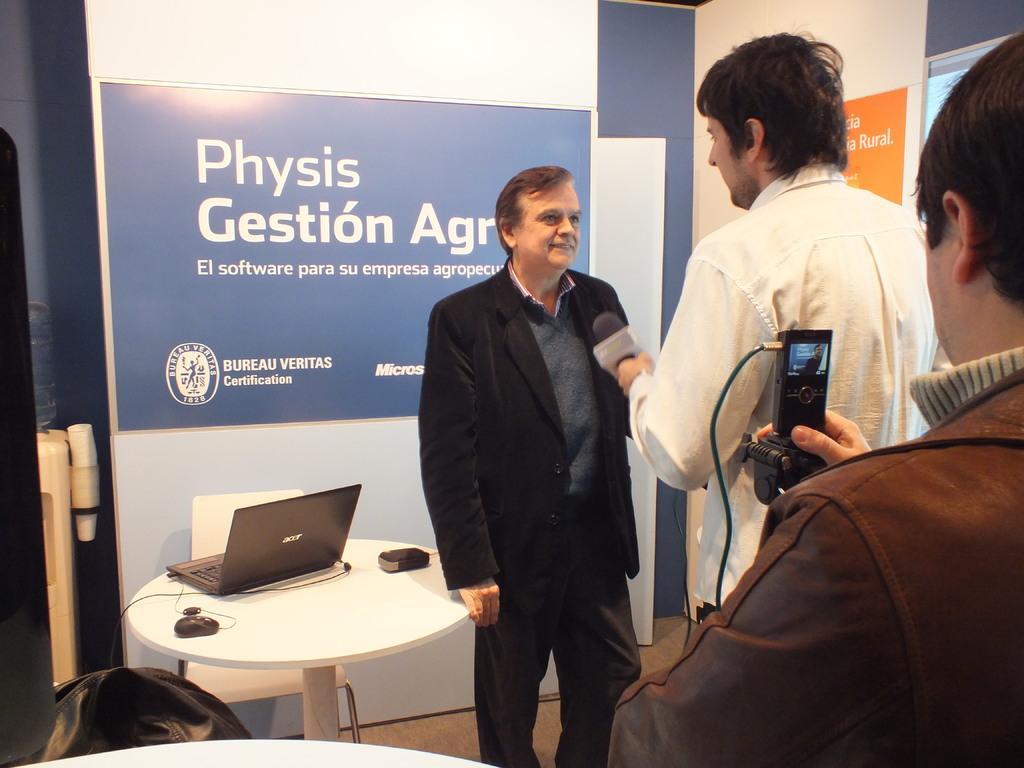How would you summarize this image in a sentence or two? In the middle there is a man he wear suit ,trouser. In the middle there is a table on the there is a laptop ,mouse and some items. In front of a table there is a chair. In the right ,there is a person he is staring towards the screen in front of him , there is another person he is holding a mic in his hand. 